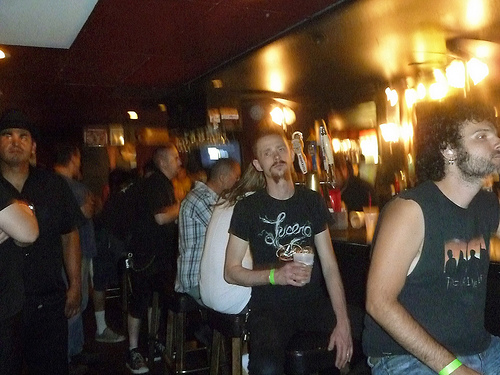<image>
Is the man behind the woman? Yes. From this viewpoint, the man is positioned behind the woman, with the woman partially or fully occluding the man. 